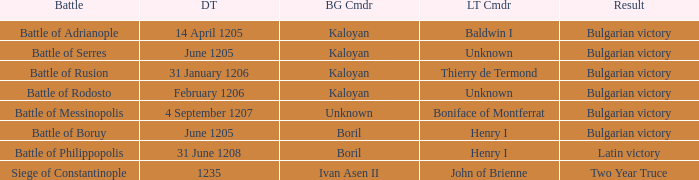What is the Result of the battle with Latin Commander Boniface of Montferrat? Bulgarian victory. 